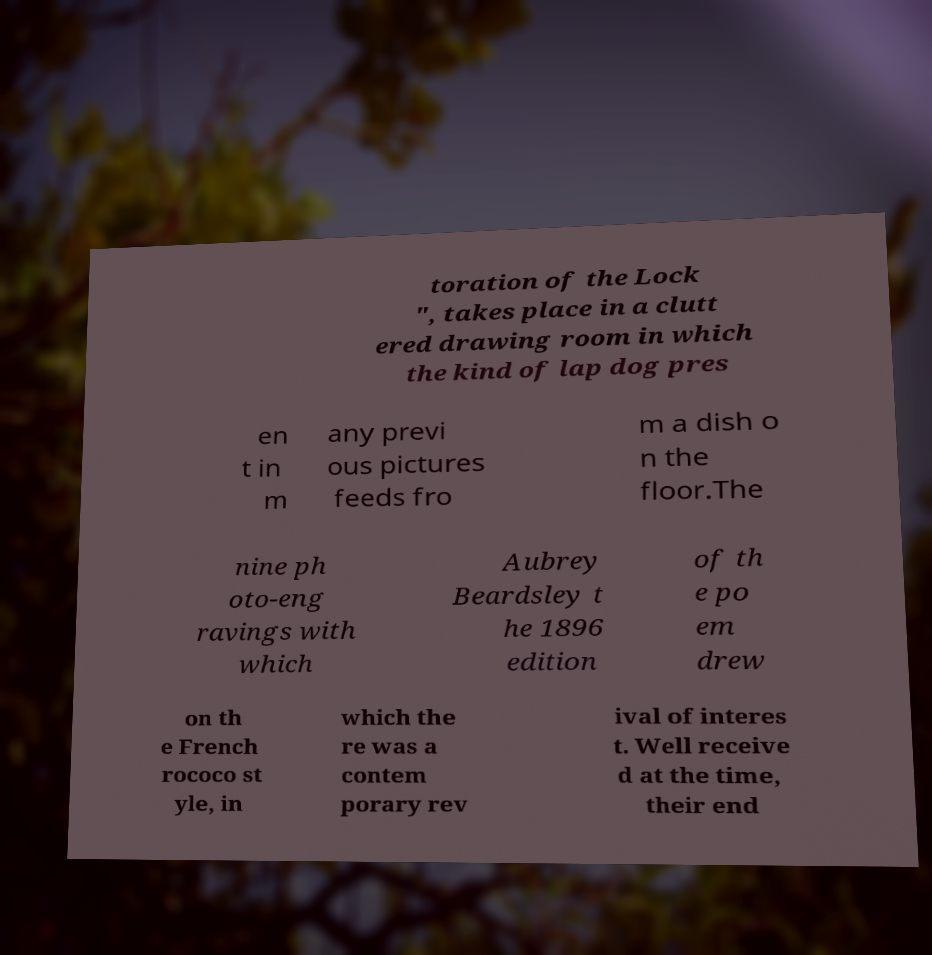Can you read and provide the text displayed in the image?This photo seems to have some interesting text. Can you extract and type it out for me? toration of the Lock ", takes place in a clutt ered drawing room in which the kind of lap dog pres en t in m any previ ous pictures feeds fro m a dish o n the floor.The nine ph oto-eng ravings with which Aubrey Beardsley t he 1896 edition of th e po em drew on th e French rococo st yle, in which the re was a contem porary rev ival of interes t. Well receive d at the time, their end 